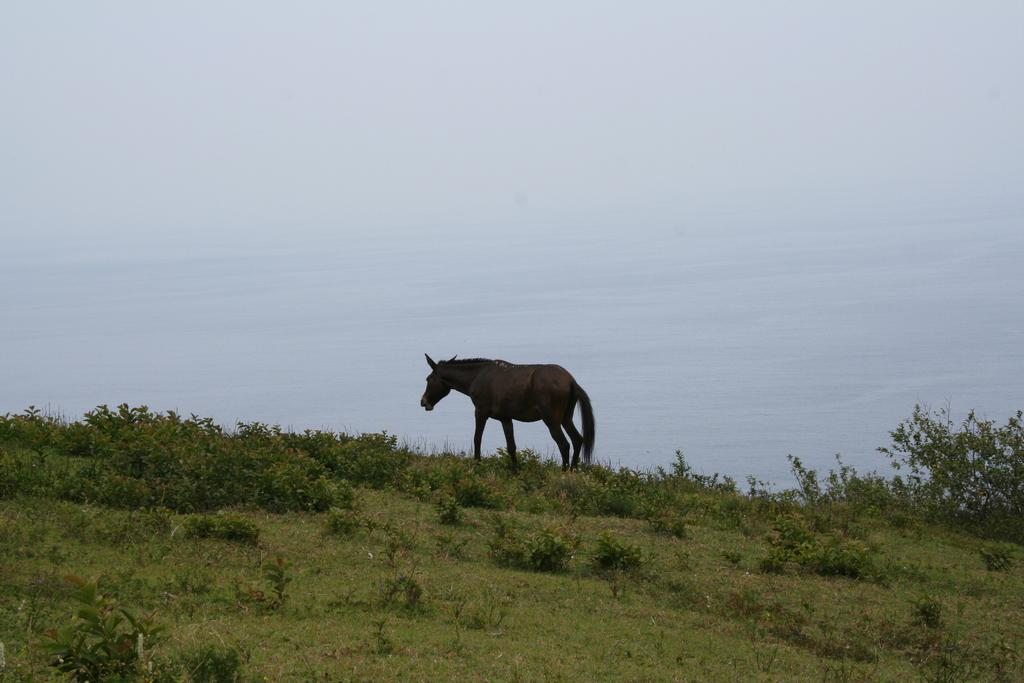What type of animal is in the image? There is an animal in the image, but the specific type cannot be determined from the provided facts. What is visible behind the animal? There is water visible behind the animal. What is in the foreground of the image? There is grass and plants in the foreground of the image. What type of secretary is visible in the image? There is no secretary present in the image; it features an animal, water, grass, and plants. What type of drain is visible in the image? There is no drain present in the image; it features an animal, water, grass, and plants. 